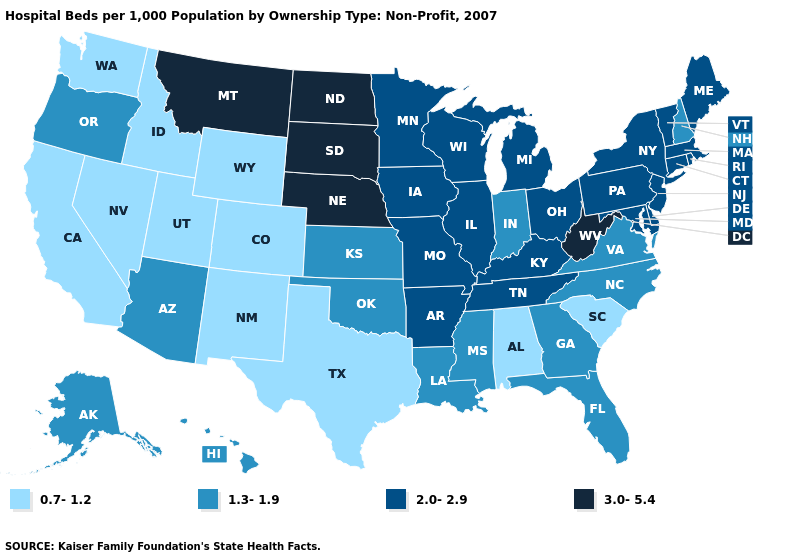How many symbols are there in the legend?
Keep it brief. 4. What is the lowest value in the USA?
Give a very brief answer. 0.7-1.2. Does Arkansas have the highest value in the South?
Concise answer only. No. How many symbols are there in the legend?
Write a very short answer. 4. Name the states that have a value in the range 2.0-2.9?
Quick response, please. Arkansas, Connecticut, Delaware, Illinois, Iowa, Kentucky, Maine, Maryland, Massachusetts, Michigan, Minnesota, Missouri, New Jersey, New York, Ohio, Pennsylvania, Rhode Island, Tennessee, Vermont, Wisconsin. Which states have the lowest value in the Northeast?
Concise answer only. New Hampshire. Which states have the lowest value in the USA?
Quick response, please. Alabama, California, Colorado, Idaho, Nevada, New Mexico, South Carolina, Texas, Utah, Washington, Wyoming. What is the value of Maryland?
Concise answer only. 2.0-2.9. Does Nevada have the lowest value in the West?
Concise answer only. Yes. What is the value of New Mexico?
Write a very short answer. 0.7-1.2. Name the states that have a value in the range 2.0-2.9?
Concise answer only. Arkansas, Connecticut, Delaware, Illinois, Iowa, Kentucky, Maine, Maryland, Massachusetts, Michigan, Minnesota, Missouri, New Jersey, New York, Ohio, Pennsylvania, Rhode Island, Tennessee, Vermont, Wisconsin. Name the states that have a value in the range 1.3-1.9?
Quick response, please. Alaska, Arizona, Florida, Georgia, Hawaii, Indiana, Kansas, Louisiana, Mississippi, New Hampshire, North Carolina, Oklahoma, Oregon, Virginia. What is the highest value in the USA?
Answer briefly. 3.0-5.4. Name the states that have a value in the range 1.3-1.9?
Keep it brief. Alaska, Arizona, Florida, Georgia, Hawaii, Indiana, Kansas, Louisiana, Mississippi, New Hampshire, North Carolina, Oklahoma, Oregon, Virginia. What is the highest value in states that border Idaho?
Short answer required. 3.0-5.4. 